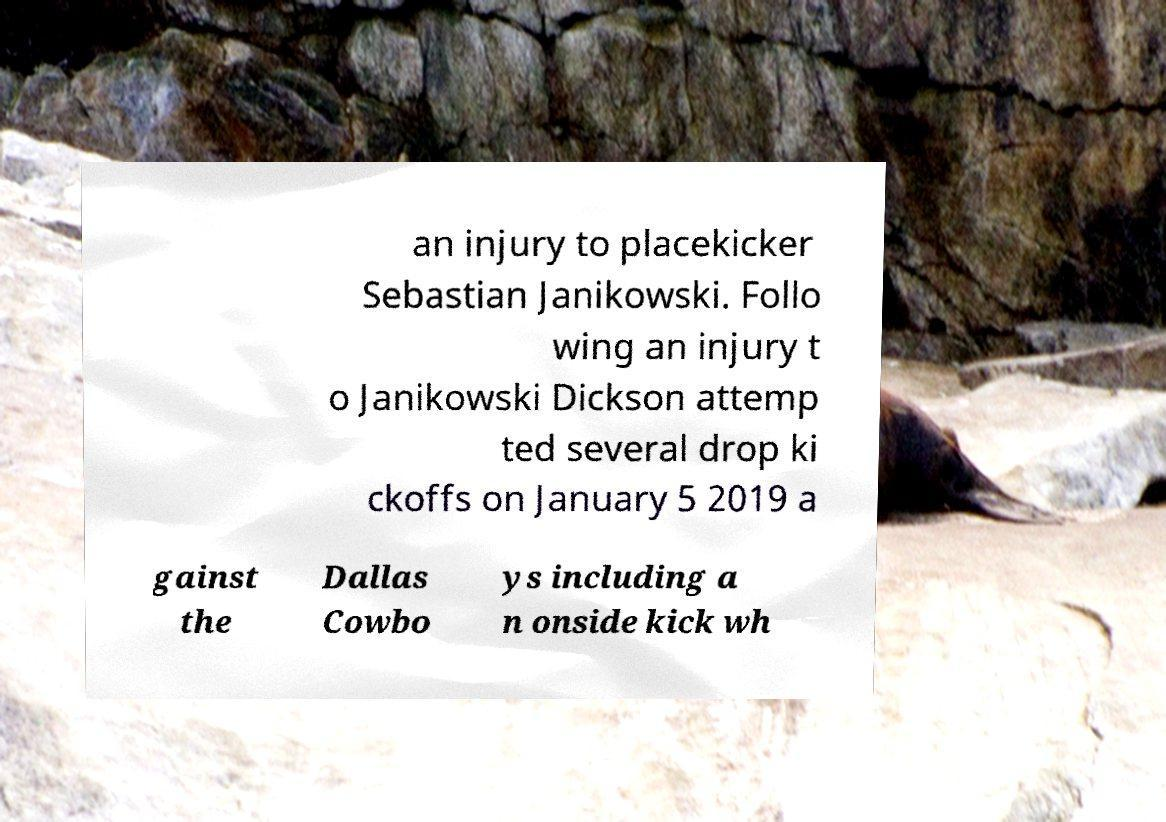Could you assist in decoding the text presented in this image and type it out clearly? an injury to placekicker Sebastian Janikowski. Follo wing an injury t o Janikowski Dickson attemp ted several drop ki ckoffs on January 5 2019 a gainst the Dallas Cowbo ys including a n onside kick wh 